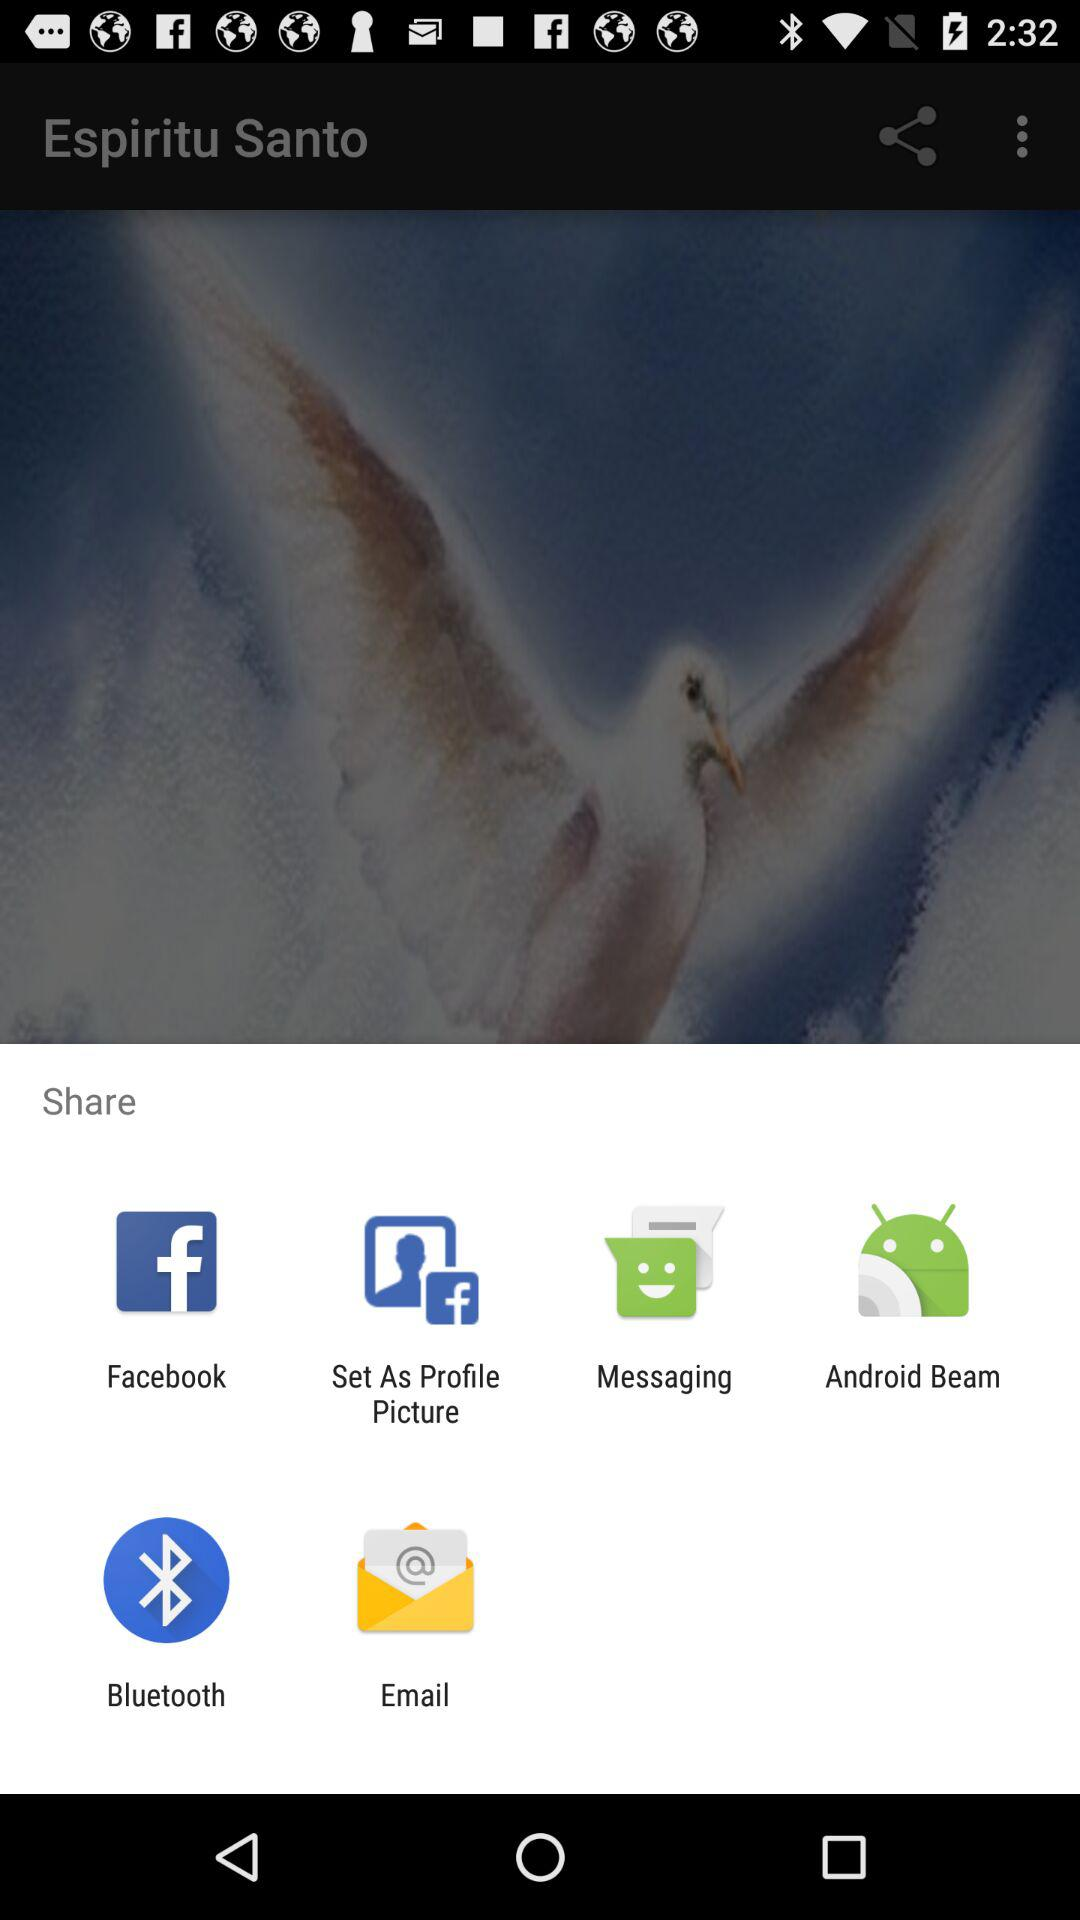What are the different mediums to share? The different mediums are "Facebook", "Set As Profile Picture", "Messaging", "Android Beam", "Bluetooth" and "Email". 